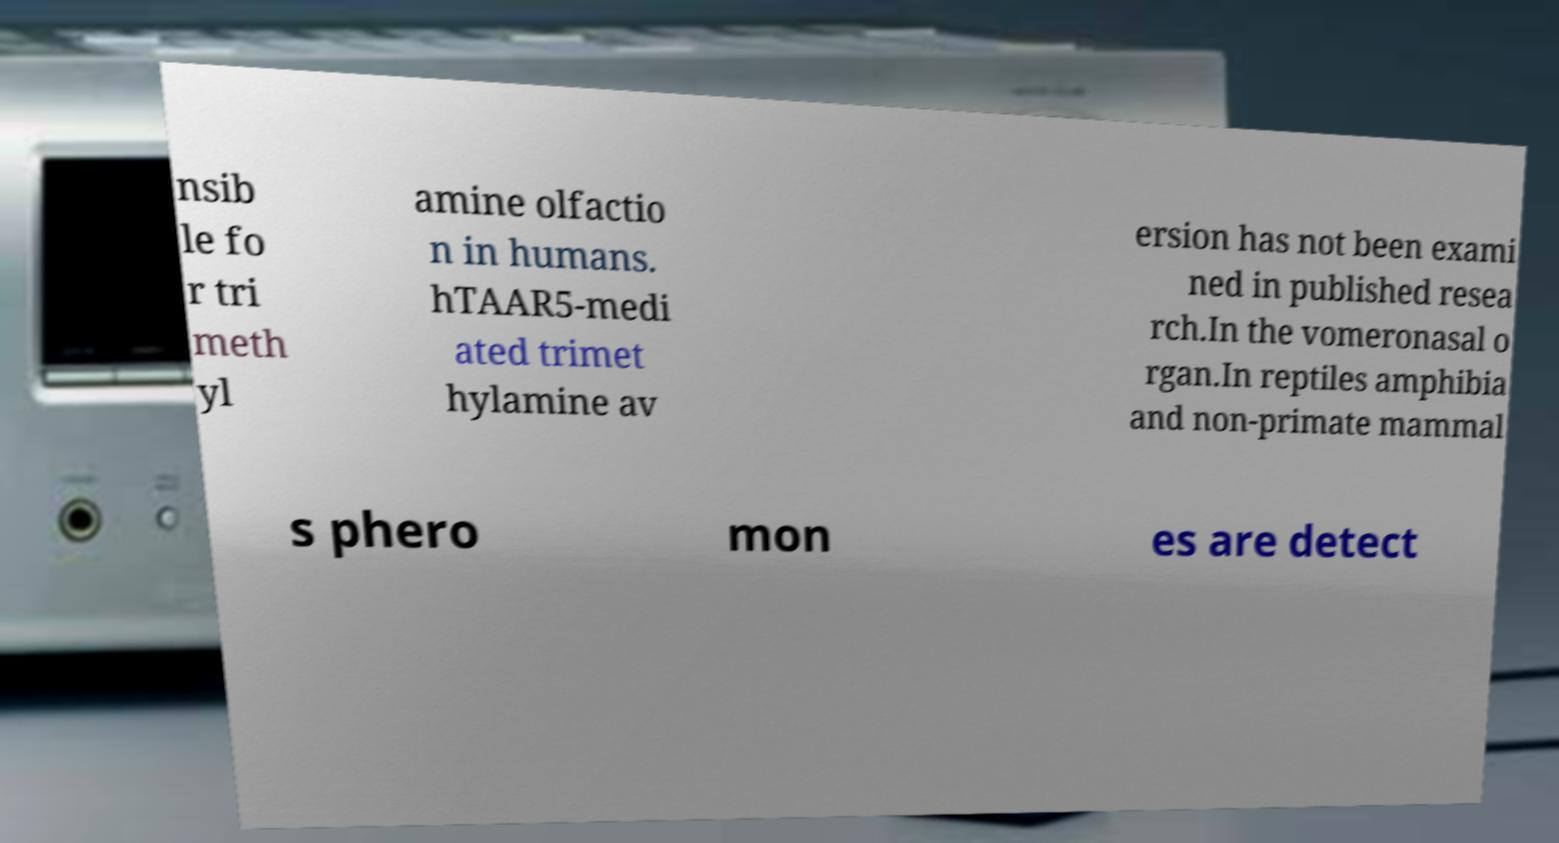What messages or text are displayed in this image? I need them in a readable, typed format. nsib le fo r tri meth yl amine olfactio n in humans. hTAAR5-medi ated trimet hylamine av ersion has not been exami ned in published resea rch.In the vomeronasal o rgan.In reptiles amphibia and non-primate mammal s phero mon es are detect 